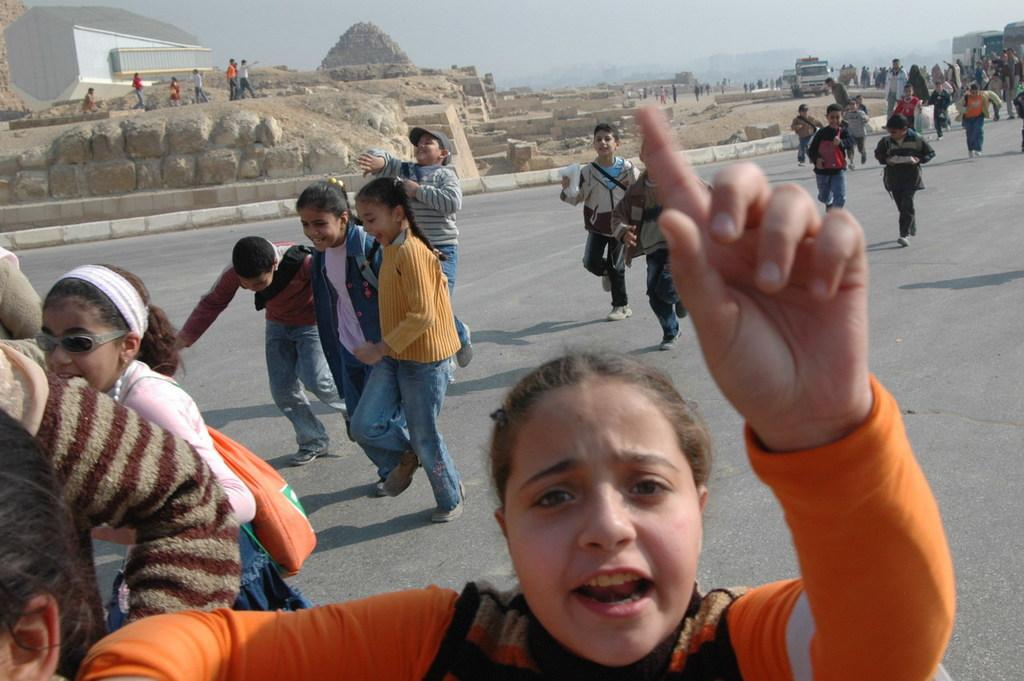Who can be seen in the image? There are people in the image. What are the kids in the image doing? Kids are running on the road in the image. What can be seen in the background of the image? There is a wall, a house, people, vehicles, and the sky visible in the background of the image. What type of jelly is being spread on the butter in the image? There is no jelly or butter present in the image; it features people and kids running on the road. How does the pollution affect the people in the image? There is no mention of pollution in the image; it only shows people and kids running on the road. 